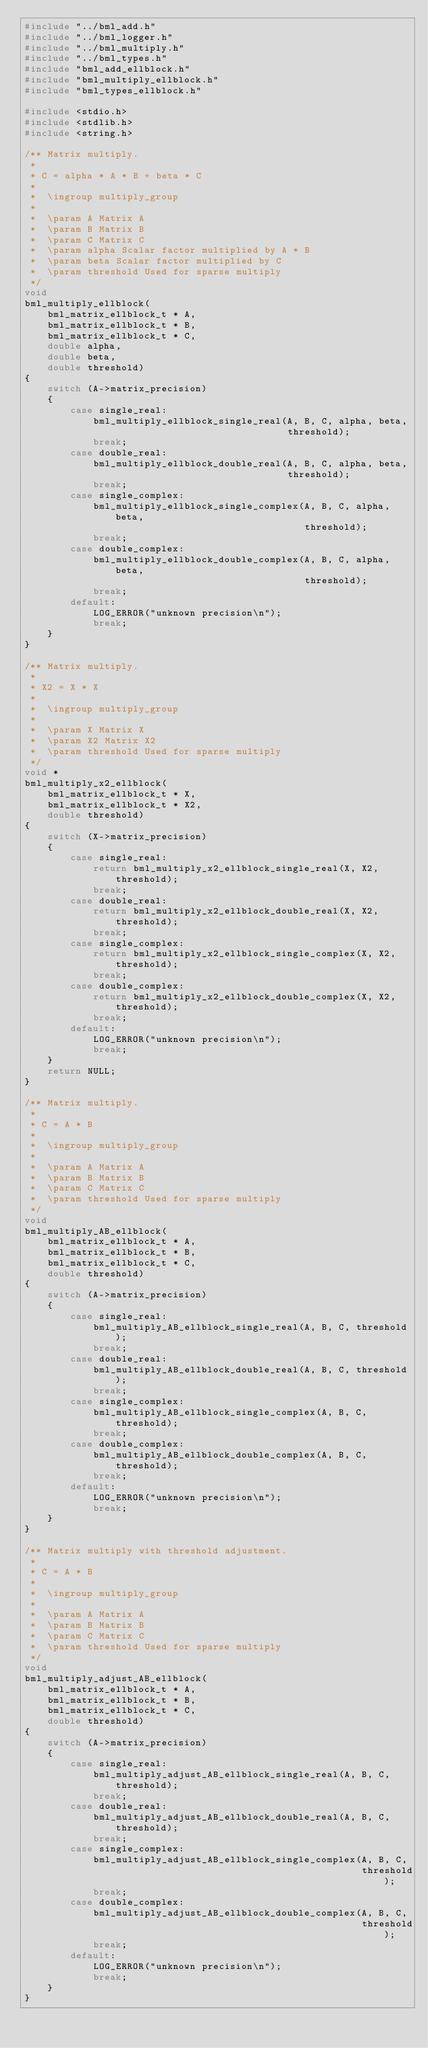Convert code to text. <code><loc_0><loc_0><loc_500><loc_500><_C_>#include "../bml_add.h"
#include "../bml_logger.h"
#include "../bml_multiply.h"
#include "../bml_types.h"
#include "bml_add_ellblock.h"
#include "bml_multiply_ellblock.h"
#include "bml_types_ellblock.h"

#include <stdio.h>
#include <stdlib.h>
#include <string.h>

/** Matrix multiply.
 *
 * C = alpha * A * B + beta * C
 *
 *  \ingroup multiply_group
 *
 *  \param A Matrix A
 *  \param B Matrix B
 *  \param C Matrix C
 *  \param alpha Scalar factor multiplied by A * B
 *  \param beta Scalar factor multiplied by C
 *  \param threshold Used for sparse multiply
 */
void
bml_multiply_ellblock(
    bml_matrix_ellblock_t * A,
    bml_matrix_ellblock_t * B,
    bml_matrix_ellblock_t * C,
    double alpha,
    double beta,
    double threshold)
{
    switch (A->matrix_precision)
    {
        case single_real:
            bml_multiply_ellblock_single_real(A, B, C, alpha, beta,
                                              threshold);
            break;
        case double_real:
            bml_multiply_ellblock_double_real(A, B, C, alpha, beta,
                                              threshold);
            break;
        case single_complex:
            bml_multiply_ellblock_single_complex(A, B, C, alpha, beta,
                                                 threshold);
            break;
        case double_complex:
            bml_multiply_ellblock_double_complex(A, B, C, alpha, beta,
                                                 threshold);
            break;
        default:
            LOG_ERROR("unknown precision\n");
            break;
    }
}

/** Matrix multiply.
 *
 * X2 = X * X
 *
 *  \ingroup multiply_group
 *
 *  \param X Matrix X
 *  \param X2 Matrix X2
 *  \param threshold Used for sparse multiply
 */
void *
bml_multiply_x2_ellblock(
    bml_matrix_ellblock_t * X,
    bml_matrix_ellblock_t * X2,
    double threshold)
{
    switch (X->matrix_precision)
    {
        case single_real:
            return bml_multiply_x2_ellblock_single_real(X, X2, threshold);
            break;
        case double_real:
            return bml_multiply_x2_ellblock_double_real(X, X2, threshold);
            break;
        case single_complex:
            return bml_multiply_x2_ellblock_single_complex(X, X2, threshold);
            break;
        case double_complex:
            return bml_multiply_x2_ellblock_double_complex(X, X2, threshold);
            break;
        default:
            LOG_ERROR("unknown precision\n");
            break;
    }
    return NULL;
}

/** Matrix multiply.
 *
 * C = A * B
 *
 *  \ingroup multiply_group
 *
 *  \param A Matrix A
 *  \param B Matrix B
 *  \param C Matrix C
 *  \param threshold Used for sparse multiply
 */
void
bml_multiply_AB_ellblock(
    bml_matrix_ellblock_t * A,
    bml_matrix_ellblock_t * B,
    bml_matrix_ellblock_t * C,
    double threshold)
{
    switch (A->matrix_precision)
    {
        case single_real:
            bml_multiply_AB_ellblock_single_real(A, B, C, threshold);
            break;
        case double_real:
            bml_multiply_AB_ellblock_double_real(A, B, C, threshold);
            break;
        case single_complex:
            bml_multiply_AB_ellblock_single_complex(A, B, C, threshold);
            break;
        case double_complex:
            bml_multiply_AB_ellblock_double_complex(A, B, C, threshold);
            break;
        default:
            LOG_ERROR("unknown precision\n");
            break;
    }
}

/** Matrix multiply with threshold adjustment.
 *
 * C = A * B
 *
 *  \ingroup multiply_group
 *
 *  \param A Matrix A
 *  \param B Matrix B
 *  \param C Matrix C
 *  \param threshold Used for sparse multiply
 */
void
bml_multiply_adjust_AB_ellblock(
    bml_matrix_ellblock_t * A,
    bml_matrix_ellblock_t * B,
    bml_matrix_ellblock_t * C,
    double threshold)
{
    switch (A->matrix_precision)
    {
        case single_real:
            bml_multiply_adjust_AB_ellblock_single_real(A, B, C, threshold);
            break;
        case double_real:
            bml_multiply_adjust_AB_ellblock_double_real(A, B, C, threshold);
            break;
        case single_complex:
            bml_multiply_adjust_AB_ellblock_single_complex(A, B, C,
                                                           threshold);
            break;
        case double_complex:
            bml_multiply_adjust_AB_ellblock_double_complex(A, B, C,
                                                           threshold);
            break;
        default:
            LOG_ERROR("unknown precision\n");
            break;
    }
}
</code> 